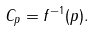Convert formula to latex. <formula><loc_0><loc_0><loc_500><loc_500>C _ { p } = f ^ { - 1 } ( p ) .</formula> 